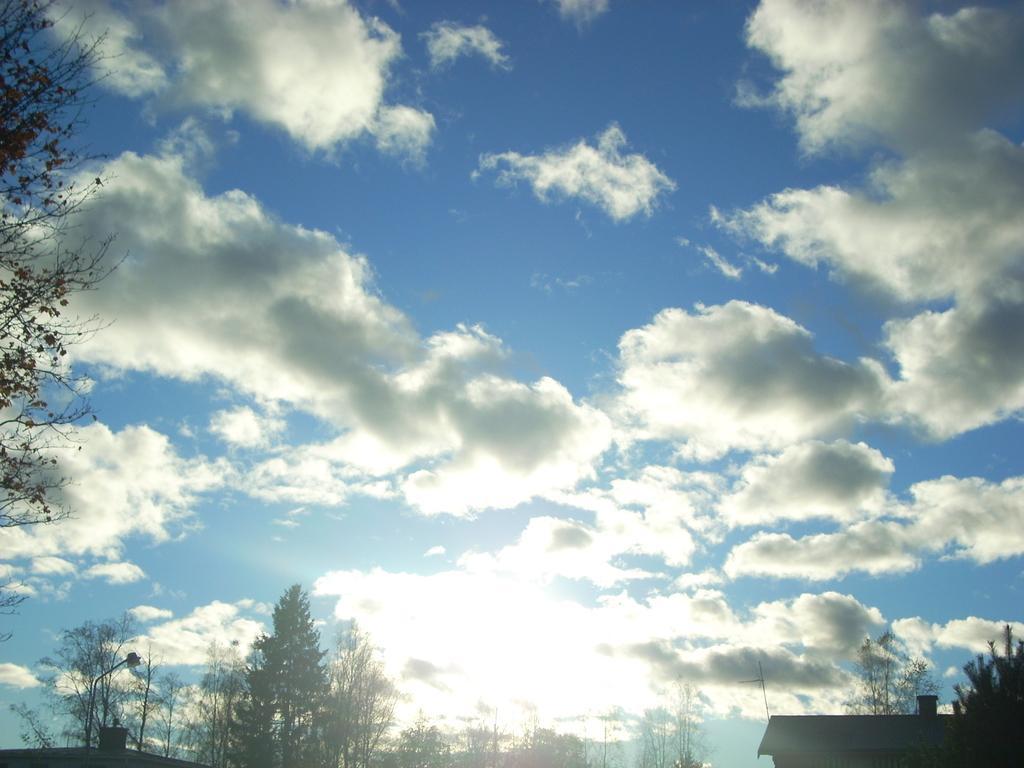How would you summarize this image in a sentence or two? In this image we can see the sky. At the bottom we can see a group of trees, buildings and a street pole with light. On the left side, we can see a tree. 